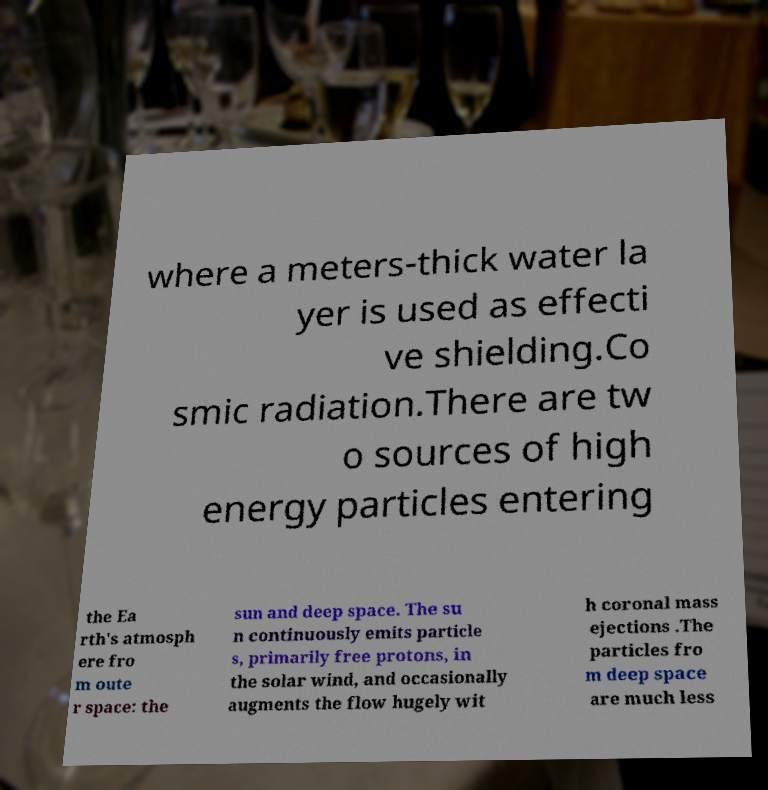Can you accurately transcribe the text from the provided image for me? where a meters-thick water la yer is used as effecti ve shielding.Co smic radiation.There are tw o sources of high energy particles entering the Ea rth's atmosph ere fro m oute r space: the sun and deep space. The su n continuously emits particle s, primarily free protons, in the solar wind, and occasionally augments the flow hugely wit h coronal mass ejections .The particles fro m deep space are much less 